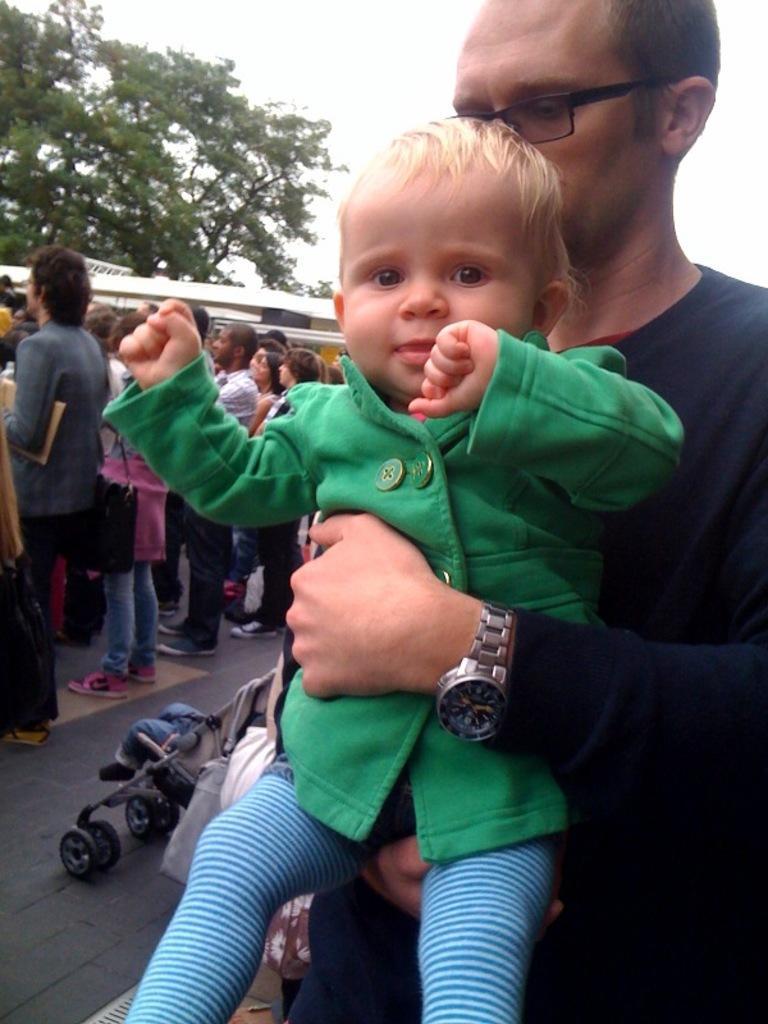Could you give a brief overview of what you see in this image? In the picture we can see a man holding a baby and beside it, we can see some people are standing and in the background we can see a part of the tree and the sky. 